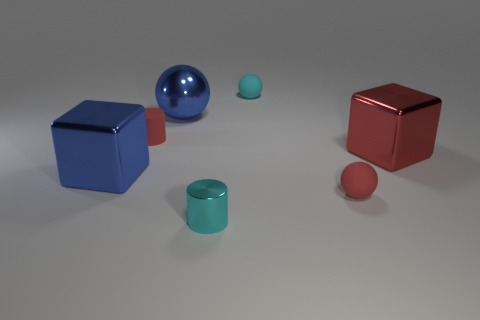Are there any large blue metal things to the left of the large red object?
Your response must be concise. Yes. There is a cube that is the same color as the rubber cylinder; what is it made of?
Make the answer very short. Metal. What number of balls are small red matte objects or big blue things?
Provide a short and direct response. 2. How big is the cylinder to the left of the cyan metal thing?
Your answer should be very brief. Small. Is there a large shiny thing of the same color as the large metallic ball?
Provide a short and direct response. Yes. Does the rubber object in front of the red block have the same size as the small shiny cylinder?
Give a very brief answer. Yes. What is the color of the metallic sphere?
Offer a very short reply. Blue. The small rubber thing to the right of the rubber sphere to the left of the red rubber ball is what color?
Your answer should be compact. Red. Is there a large thing that has the same material as the blue cube?
Your answer should be very brief. Yes. What material is the small cylinder that is on the left side of the big thing behind the big red metal object?
Provide a short and direct response. Rubber. 